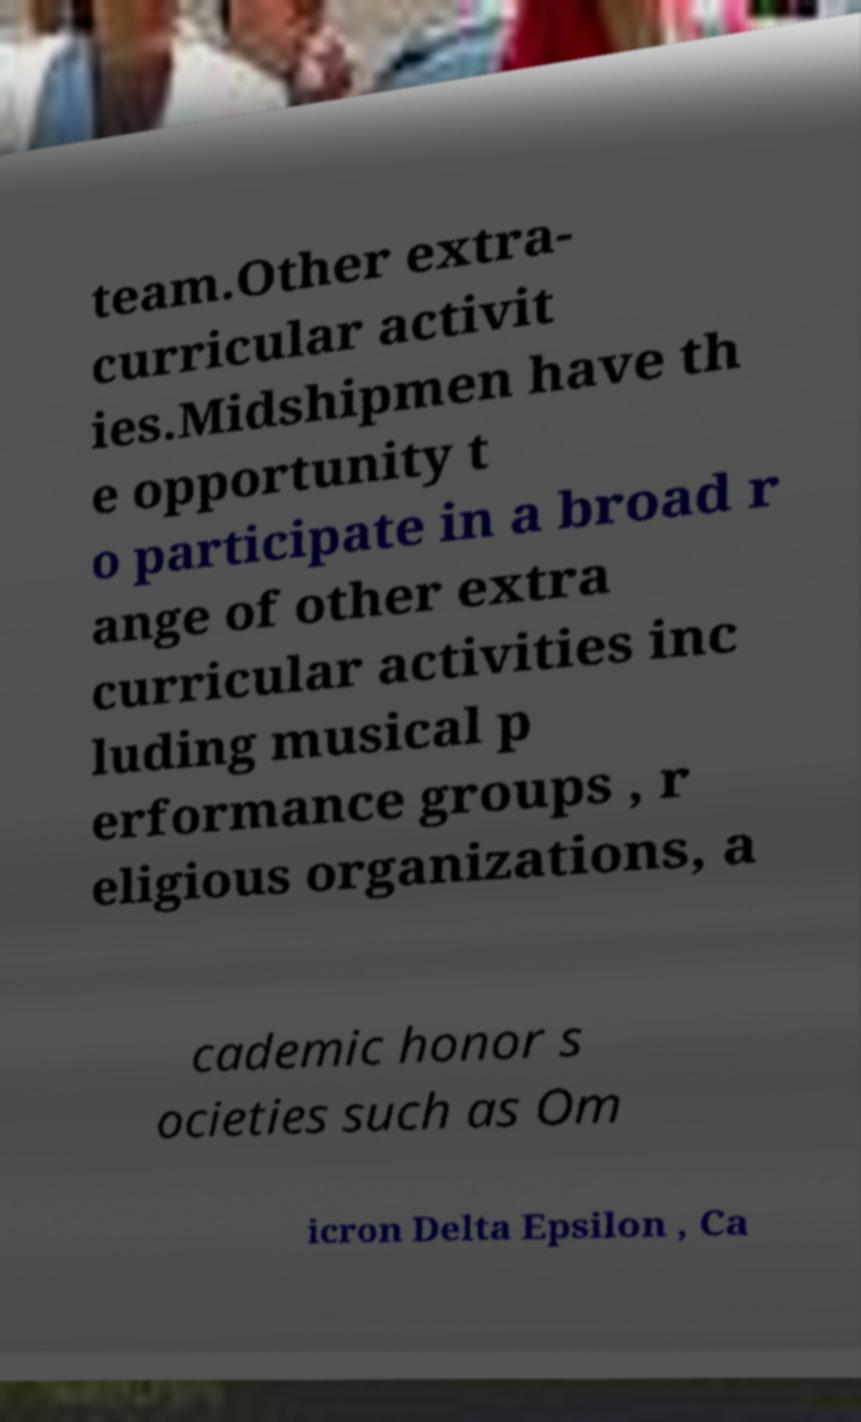What messages or text are displayed in this image? I need them in a readable, typed format. team.Other extra- curricular activit ies.Midshipmen have th e opportunity t o participate in a broad r ange of other extra curricular activities inc luding musical p erformance groups , r eligious organizations, a cademic honor s ocieties such as Om icron Delta Epsilon , Ca 